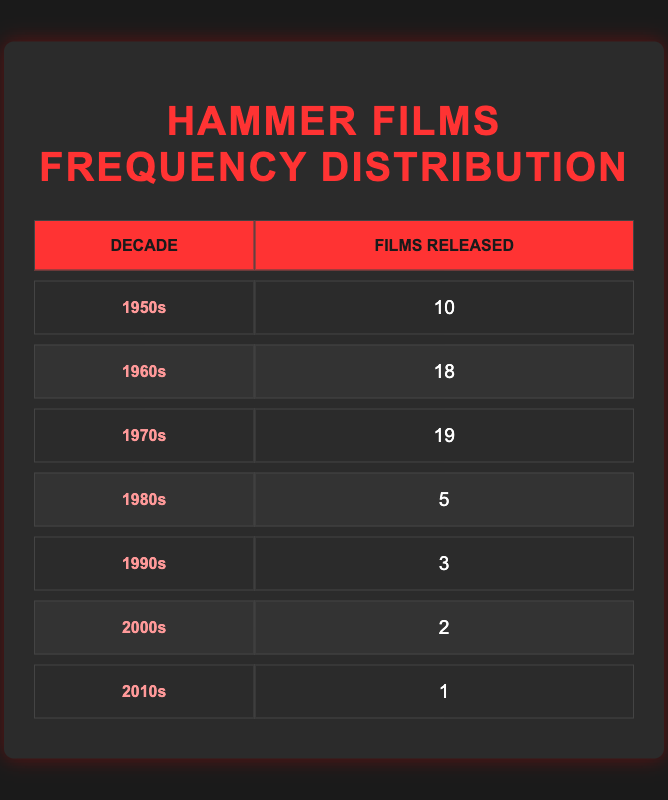What decade had the highest number of Hammer films released? By looking at the "Films Released" column, the 1970s has the highest value of 19, which is more than any other decade.
Answer: 1970s How many Hammer films were released in the 1960s? The specific number for the 1960s is clearly stated as 18 films in the "Films Released" column.
Answer: 18 What is the total number of Hammer films released from the 1980s to the 2010s? To find the total, we add the values from the 1980s (5), 1990s (3), 2000s (2), and 2010s (1), which sums up as 5 + 3 + 2 + 1 = 11.
Answer: 11 Is it true that fewer than 15 films were released in the 1950s? The data shows that 10 films were released in the 1950s, which is indeed fewer than 15.
Answer: Yes How does the number of films released in the 1950s compare to the 1980s? The 1950s had 10 films while the 1980s had 5 films. Comparing these shows that 10 is greater than 5, meaning the 1950s had more films released than the 1980s.
Answer: The 1950s had more films released 